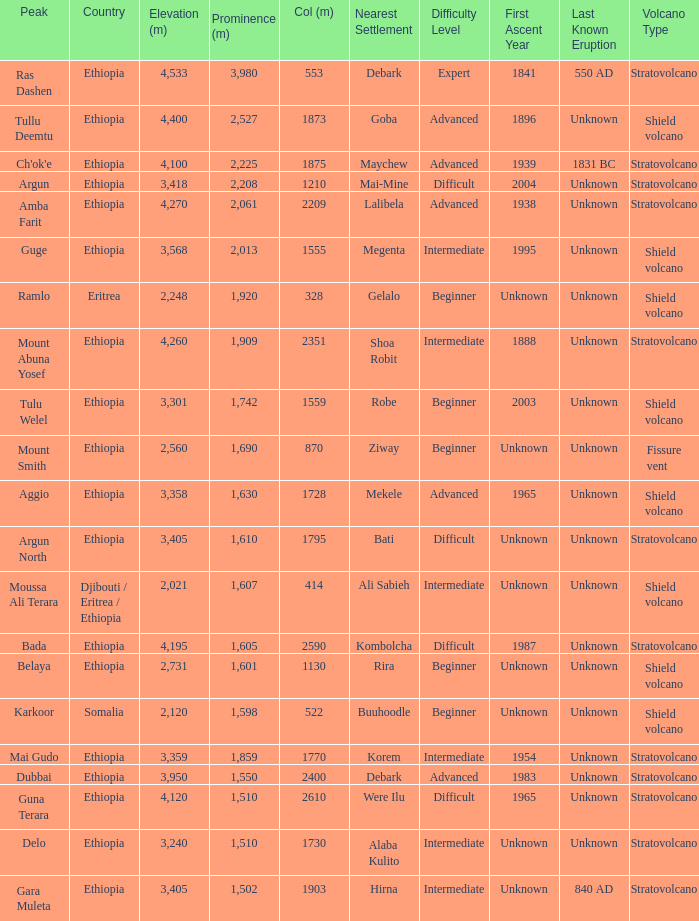What is the sum of the prominence in m of moussa ali terara peak? 1607.0. 